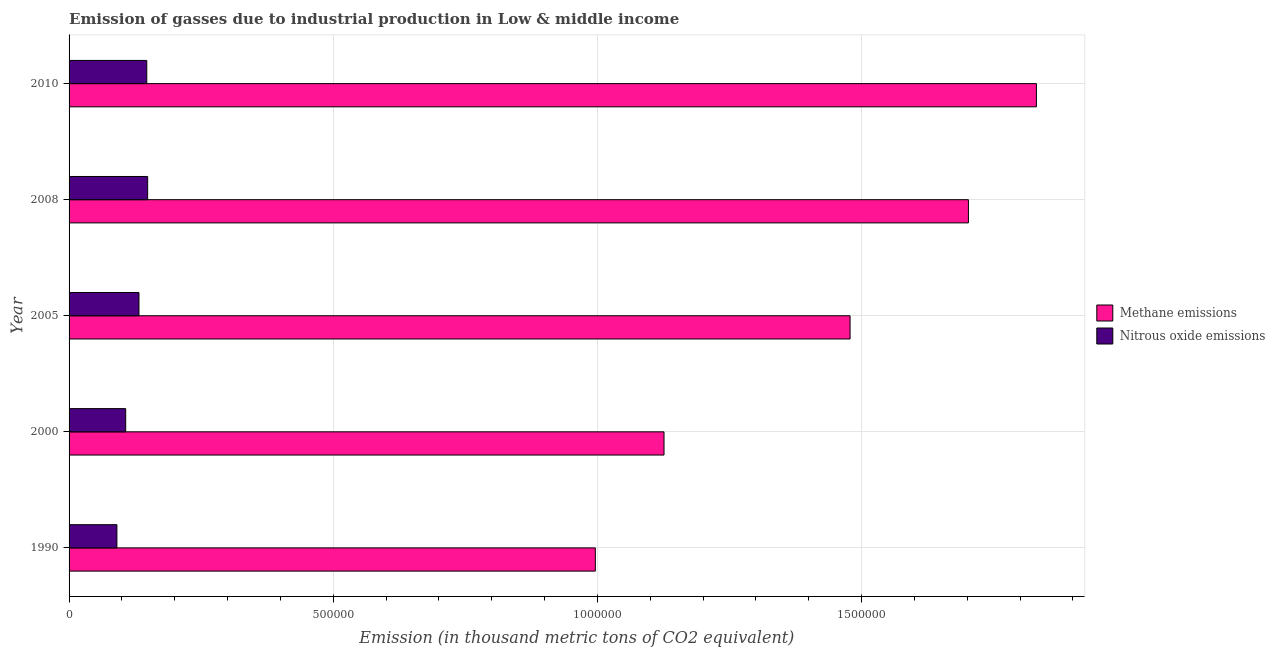How many groups of bars are there?
Keep it short and to the point. 5. Are the number of bars per tick equal to the number of legend labels?
Provide a short and direct response. Yes. Are the number of bars on each tick of the Y-axis equal?
Keep it short and to the point. Yes. How many bars are there on the 2nd tick from the bottom?
Offer a terse response. 2. What is the amount of methane emissions in 2000?
Your response must be concise. 1.13e+06. Across all years, what is the maximum amount of methane emissions?
Ensure brevity in your answer.  1.83e+06. Across all years, what is the minimum amount of methane emissions?
Keep it short and to the point. 9.96e+05. What is the total amount of nitrous oxide emissions in the graph?
Offer a very short reply. 6.26e+05. What is the difference between the amount of nitrous oxide emissions in 1990 and that in 2010?
Provide a succinct answer. -5.65e+04. What is the difference between the amount of methane emissions in 2000 and the amount of nitrous oxide emissions in 2005?
Your response must be concise. 9.94e+05. What is the average amount of nitrous oxide emissions per year?
Give a very brief answer. 1.25e+05. In the year 2000, what is the difference between the amount of nitrous oxide emissions and amount of methane emissions?
Make the answer very short. -1.02e+06. In how many years, is the amount of methane emissions greater than 1000000 thousand metric tons?
Your response must be concise. 4. What is the ratio of the amount of methane emissions in 2005 to that in 2008?
Offer a very short reply. 0.87. What is the difference between the highest and the second highest amount of methane emissions?
Your answer should be compact. 1.29e+05. What is the difference between the highest and the lowest amount of nitrous oxide emissions?
Your response must be concise. 5.82e+04. In how many years, is the amount of methane emissions greater than the average amount of methane emissions taken over all years?
Ensure brevity in your answer.  3. Is the sum of the amount of methane emissions in 2000 and 2010 greater than the maximum amount of nitrous oxide emissions across all years?
Offer a terse response. Yes. What does the 2nd bar from the top in 2000 represents?
Your answer should be very brief. Methane emissions. What does the 1st bar from the bottom in 2008 represents?
Make the answer very short. Methane emissions. How many bars are there?
Your answer should be very brief. 10. How many years are there in the graph?
Provide a succinct answer. 5. What is the difference between two consecutive major ticks on the X-axis?
Keep it short and to the point. 5.00e+05. Are the values on the major ticks of X-axis written in scientific E-notation?
Provide a short and direct response. No. Does the graph contain any zero values?
Make the answer very short. No. Does the graph contain grids?
Offer a very short reply. Yes. Where does the legend appear in the graph?
Your response must be concise. Center right. How many legend labels are there?
Make the answer very short. 2. What is the title of the graph?
Give a very brief answer. Emission of gasses due to industrial production in Low & middle income. Does "National Visitors" appear as one of the legend labels in the graph?
Your answer should be compact. No. What is the label or title of the X-axis?
Provide a succinct answer. Emission (in thousand metric tons of CO2 equivalent). What is the Emission (in thousand metric tons of CO2 equivalent) of Methane emissions in 1990?
Provide a succinct answer. 9.96e+05. What is the Emission (in thousand metric tons of CO2 equivalent) in Nitrous oxide emissions in 1990?
Offer a very short reply. 9.05e+04. What is the Emission (in thousand metric tons of CO2 equivalent) of Methane emissions in 2000?
Give a very brief answer. 1.13e+06. What is the Emission (in thousand metric tons of CO2 equivalent) in Nitrous oxide emissions in 2000?
Your answer should be compact. 1.07e+05. What is the Emission (in thousand metric tons of CO2 equivalent) in Methane emissions in 2005?
Make the answer very short. 1.48e+06. What is the Emission (in thousand metric tons of CO2 equivalent) in Nitrous oxide emissions in 2005?
Give a very brief answer. 1.32e+05. What is the Emission (in thousand metric tons of CO2 equivalent) of Methane emissions in 2008?
Your answer should be compact. 1.70e+06. What is the Emission (in thousand metric tons of CO2 equivalent) of Nitrous oxide emissions in 2008?
Your response must be concise. 1.49e+05. What is the Emission (in thousand metric tons of CO2 equivalent) of Methane emissions in 2010?
Your answer should be compact. 1.83e+06. What is the Emission (in thousand metric tons of CO2 equivalent) of Nitrous oxide emissions in 2010?
Offer a terse response. 1.47e+05. Across all years, what is the maximum Emission (in thousand metric tons of CO2 equivalent) in Methane emissions?
Your answer should be very brief. 1.83e+06. Across all years, what is the maximum Emission (in thousand metric tons of CO2 equivalent) in Nitrous oxide emissions?
Offer a very short reply. 1.49e+05. Across all years, what is the minimum Emission (in thousand metric tons of CO2 equivalent) in Methane emissions?
Provide a succinct answer. 9.96e+05. Across all years, what is the minimum Emission (in thousand metric tons of CO2 equivalent) of Nitrous oxide emissions?
Your response must be concise. 9.05e+04. What is the total Emission (in thousand metric tons of CO2 equivalent) in Methane emissions in the graph?
Your answer should be compact. 7.13e+06. What is the total Emission (in thousand metric tons of CO2 equivalent) of Nitrous oxide emissions in the graph?
Give a very brief answer. 6.26e+05. What is the difference between the Emission (in thousand metric tons of CO2 equivalent) in Methane emissions in 1990 and that in 2000?
Give a very brief answer. -1.30e+05. What is the difference between the Emission (in thousand metric tons of CO2 equivalent) in Nitrous oxide emissions in 1990 and that in 2000?
Your response must be concise. -1.66e+04. What is the difference between the Emission (in thousand metric tons of CO2 equivalent) in Methane emissions in 1990 and that in 2005?
Keep it short and to the point. -4.82e+05. What is the difference between the Emission (in thousand metric tons of CO2 equivalent) of Nitrous oxide emissions in 1990 and that in 2005?
Ensure brevity in your answer.  -4.18e+04. What is the difference between the Emission (in thousand metric tons of CO2 equivalent) of Methane emissions in 1990 and that in 2008?
Make the answer very short. -7.06e+05. What is the difference between the Emission (in thousand metric tons of CO2 equivalent) in Nitrous oxide emissions in 1990 and that in 2008?
Offer a terse response. -5.82e+04. What is the difference between the Emission (in thousand metric tons of CO2 equivalent) in Methane emissions in 1990 and that in 2010?
Your response must be concise. -8.35e+05. What is the difference between the Emission (in thousand metric tons of CO2 equivalent) in Nitrous oxide emissions in 1990 and that in 2010?
Your answer should be compact. -5.65e+04. What is the difference between the Emission (in thousand metric tons of CO2 equivalent) of Methane emissions in 2000 and that in 2005?
Your answer should be very brief. -3.52e+05. What is the difference between the Emission (in thousand metric tons of CO2 equivalent) in Nitrous oxide emissions in 2000 and that in 2005?
Make the answer very short. -2.51e+04. What is the difference between the Emission (in thousand metric tons of CO2 equivalent) of Methane emissions in 2000 and that in 2008?
Keep it short and to the point. -5.76e+05. What is the difference between the Emission (in thousand metric tons of CO2 equivalent) in Nitrous oxide emissions in 2000 and that in 2008?
Your response must be concise. -4.16e+04. What is the difference between the Emission (in thousand metric tons of CO2 equivalent) in Methane emissions in 2000 and that in 2010?
Your answer should be very brief. -7.05e+05. What is the difference between the Emission (in thousand metric tons of CO2 equivalent) of Nitrous oxide emissions in 2000 and that in 2010?
Offer a very short reply. -3.99e+04. What is the difference between the Emission (in thousand metric tons of CO2 equivalent) of Methane emissions in 2005 and that in 2008?
Make the answer very short. -2.24e+05. What is the difference between the Emission (in thousand metric tons of CO2 equivalent) of Nitrous oxide emissions in 2005 and that in 2008?
Keep it short and to the point. -1.64e+04. What is the difference between the Emission (in thousand metric tons of CO2 equivalent) in Methane emissions in 2005 and that in 2010?
Keep it short and to the point. -3.53e+05. What is the difference between the Emission (in thousand metric tons of CO2 equivalent) in Nitrous oxide emissions in 2005 and that in 2010?
Provide a succinct answer. -1.47e+04. What is the difference between the Emission (in thousand metric tons of CO2 equivalent) in Methane emissions in 2008 and that in 2010?
Provide a short and direct response. -1.29e+05. What is the difference between the Emission (in thousand metric tons of CO2 equivalent) in Nitrous oxide emissions in 2008 and that in 2010?
Give a very brief answer. 1688.4. What is the difference between the Emission (in thousand metric tons of CO2 equivalent) in Methane emissions in 1990 and the Emission (in thousand metric tons of CO2 equivalent) in Nitrous oxide emissions in 2000?
Your response must be concise. 8.89e+05. What is the difference between the Emission (in thousand metric tons of CO2 equivalent) in Methane emissions in 1990 and the Emission (in thousand metric tons of CO2 equivalent) in Nitrous oxide emissions in 2005?
Offer a terse response. 8.64e+05. What is the difference between the Emission (in thousand metric tons of CO2 equivalent) of Methane emissions in 1990 and the Emission (in thousand metric tons of CO2 equivalent) of Nitrous oxide emissions in 2008?
Your response must be concise. 8.47e+05. What is the difference between the Emission (in thousand metric tons of CO2 equivalent) in Methane emissions in 1990 and the Emission (in thousand metric tons of CO2 equivalent) in Nitrous oxide emissions in 2010?
Your response must be concise. 8.49e+05. What is the difference between the Emission (in thousand metric tons of CO2 equivalent) in Methane emissions in 2000 and the Emission (in thousand metric tons of CO2 equivalent) in Nitrous oxide emissions in 2005?
Your answer should be compact. 9.94e+05. What is the difference between the Emission (in thousand metric tons of CO2 equivalent) of Methane emissions in 2000 and the Emission (in thousand metric tons of CO2 equivalent) of Nitrous oxide emissions in 2008?
Give a very brief answer. 9.77e+05. What is the difference between the Emission (in thousand metric tons of CO2 equivalent) in Methane emissions in 2000 and the Emission (in thousand metric tons of CO2 equivalent) in Nitrous oxide emissions in 2010?
Provide a short and direct response. 9.79e+05. What is the difference between the Emission (in thousand metric tons of CO2 equivalent) in Methane emissions in 2005 and the Emission (in thousand metric tons of CO2 equivalent) in Nitrous oxide emissions in 2008?
Keep it short and to the point. 1.33e+06. What is the difference between the Emission (in thousand metric tons of CO2 equivalent) in Methane emissions in 2005 and the Emission (in thousand metric tons of CO2 equivalent) in Nitrous oxide emissions in 2010?
Provide a short and direct response. 1.33e+06. What is the difference between the Emission (in thousand metric tons of CO2 equivalent) in Methane emissions in 2008 and the Emission (in thousand metric tons of CO2 equivalent) in Nitrous oxide emissions in 2010?
Offer a very short reply. 1.56e+06. What is the average Emission (in thousand metric tons of CO2 equivalent) of Methane emissions per year?
Offer a terse response. 1.43e+06. What is the average Emission (in thousand metric tons of CO2 equivalent) of Nitrous oxide emissions per year?
Keep it short and to the point. 1.25e+05. In the year 1990, what is the difference between the Emission (in thousand metric tons of CO2 equivalent) in Methane emissions and Emission (in thousand metric tons of CO2 equivalent) in Nitrous oxide emissions?
Provide a succinct answer. 9.06e+05. In the year 2000, what is the difference between the Emission (in thousand metric tons of CO2 equivalent) of Methane emissions and Emission (in thousand metric tons of CO2 equivalent) of Nitrous oxide emissions?
Ensure brevity in your answer.  1.02e+06. In the year 2005, what is the difference between the Emission (in thousand metric tons of CO2 equivalent) in Methane emissions and Emission (in thousand metric tons of CO2 equivalent) in Nitrous oxide emissions?
Your answer should be compact. 1.35e+06. In the year 2008, what is the difference between the Emission (in thousand metric tons of CO2 equivalent) in Methane emissions and Emission (in thousand metric tons of CO2 equivalent) in Nitrous oxide emissions?
Your answer should be compact. 1.55e+06. In the year 2010, what is the difference between the Emission (in thousand metric tons of CO2 equivalent) in Methane emissions and Emission (in thousand metric tons of CO2 equivalent) in Nitrous oxide emissions?
Offer a terse response. 1.68e+06. What is the ratio of the Emission (in thousand metric tons of CO2 equivalent) in Methane emissions in 1990 to that in 2000?
Your answer should be very brief. 0.88. What is the ratio of the Emission (in thousand metric tons of CO2 equivalent) in Nitrous oxide emissions in 1990 to that in 2000?
Your answer should be very brief. 0.84. What is the ratio of the Emission (in thousand metric tons of CO2 equivalent) in Methane emissions in 1990 to that in 2005?
Your answer should be compact. 0.67. What is the ratio of the Emission (in thousand metric tons of CO2 equivalent) of Nitrous oxide emissions in 1990 to that in 2005?
Keep it short and to the point. 0.68. What is the ratio of the Emission (in thousand metric tons of CO2 equivalent) in Methane emissions in 1990 to that in 2008?
Offer a terse response. 0.59. What is the ratio of the Emission (in thousand metric tons of CO2 equivalent) in Nitrous oxide emissions in 1990 to that in 2008?
Make the answer very short. 0.61. What is the ratio of the Emission (in thousand metric tons of CO2 equivalent) in Methane emissions in 1990 to that in 2010?
Offer a very short reply. 0.54. What is the ratio of the Emission (in thousand metric tons of CO2 equivalent) in Nitrous oxide emissions in 1990 to that in 2010?
Your response must be concise. 0.62. What is the ratio of the Emission (in thousand metric tons of CO2 equivalent) of Methane emissions in 2000 to that in 2005?
Make the answer very short. 0.76. What is the ratio of the Emission (in thousand metric tons of CO2 equivalent) in Nitrous oxide emissions in 2000 to that in 2005?
Your answer should be compact. 0.81. What is the ratio of the Emission (in thousand metric tons of CO2 equivalent) of Methane emissions in 2000 to that in 2008?
Ensure brevity in your answer.  0.66. What is the ratio of the Emission (in thousand metric tons of CO2 equivalent) of Nitrous oxide emissions in 2000 to that in 2008?
Provide a short and direct response. 0.72. What is the ratio of the Emission (in thousand metric tons of CO2 equivalent) in Methane emissions in 2000 to that in 2010?
Your response must be concise. 0.61. What is the ratio of the Emission (in thousand metric tons of CO2 equivalent) of Nitrous oxide emissions in 2000 to that in 2010?
Give a very brief answer. 0.73. What is the ratio of the Emission (in thousand metric tons of CO2 equivalent) of Methane emissions in 2005 to that in 2008?
Your answer should be very brief. 0.87. What is the ratio of the Emission (in thousand metric tons of CO2 equivalent) in Nitrous oxide emissions in 2005 to that in 2008?
Your answer should be very brief. 0.89. What is the ratio of the Emission (in thousand metric tons of CO2 equivalent) in Methane emissions in 2005 to that in 2010?
Keep it short and to the point. 0.81. What is the ratio of the Emission (in thousand metric tons of CO2 equivalent) of Nitrous oxide emissions in 2005 to that in 2010?
Keep it short and to the point. 0.9. What is the ratio of the Emission (in thousand metric tons of CO2 equivalent) in Methane emissions in 2008 to that in 2010?
Your answer should be compact. 0.93. What is the ratio of the Emission (in thousand metric tons of CO2 equivalent) in Nitrous oxide emissions in 2008 to that in 2010?
Keep it short and to the point. 1.01. What is the difference between the highest and the second highest Emission (in thousand metric tons of CO2 equivalent) in Methane emissions?
Your response must be concise. 1.29e+05. What is the difference between the highest and the second highest Emission (in thousand metric tons of CO2 equivalent) of Nitrous oxide emissions?
Ensure brevity in your answer.  1688.4. What is the difference between the highest and the lowest Emission (in thousand metric tons of CO2 equivalent) of Methane emissions?
Your response must be concise. 8.35e+05. What is the difference between the highest and the lowest Emission (in thousand metric tons of CO2 equivalent) in Nitrous oxide emissions?
Make the answer very short. 5.82e+04. 